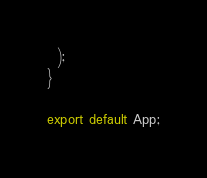<code> <loc_0><loc_0><loc_500><loc_500><_JavaScript_>  );
}

export default App;
</code> 